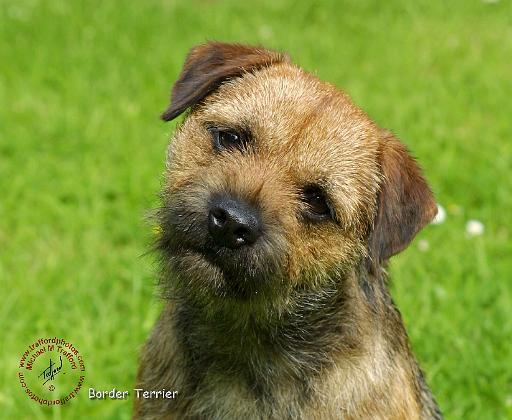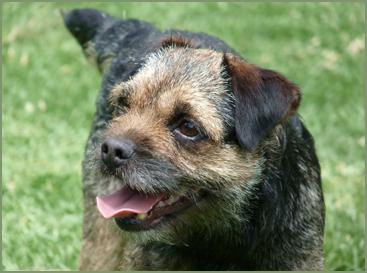The first image is the image on the left, the second image is the image on the right. Analyze the images presented: Is the assertion "A dog is looking directly at the camera in both images." valid? Answer yes or no. No. 